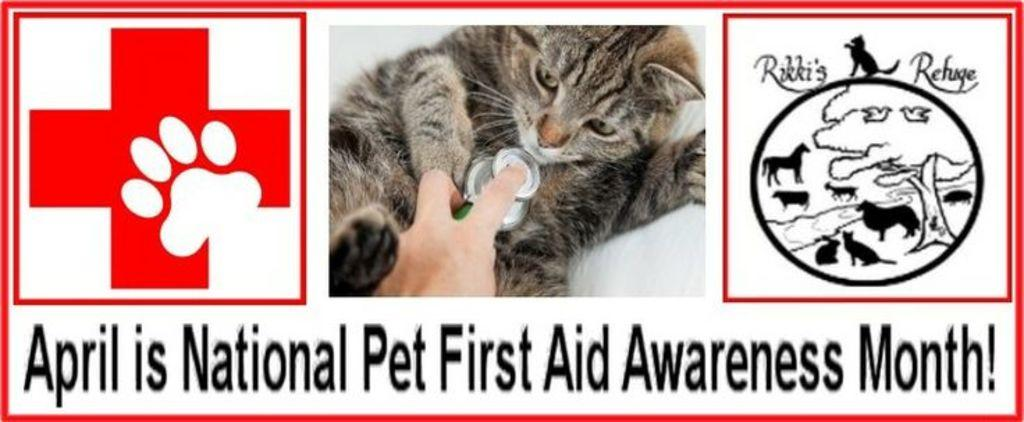What can be seen in the image that represents a brand or company? There are logos in the image. What type of animal is present in the image? There is a cat in the image. What is the person in the image doing with an object? There is a person holding an object in the image. What type of written information is present in the image? There is text in the image. What flavor of dinner is the cat eating in the image? There is no dinner or cat eating dinner in the image. How does the person in the image show respect to the cat? The image does not depict the person showing respect to the cat, nor is there a cat being held by the person. 